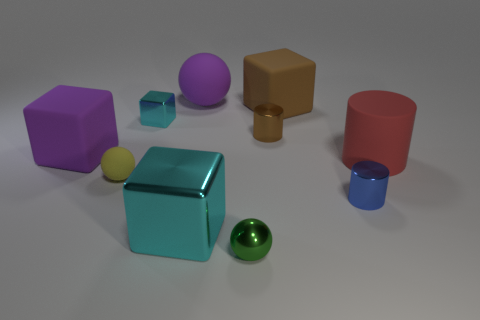What sort of environment do you think these objects are placed in? The objects are arranged on what seems like a smooth, reflective surface, which coupled with a soft shadow around each object, suggests they are likely in a controlled, perhaps indoor environment with soft lighting, likely meant for a display or photographic purposes. 